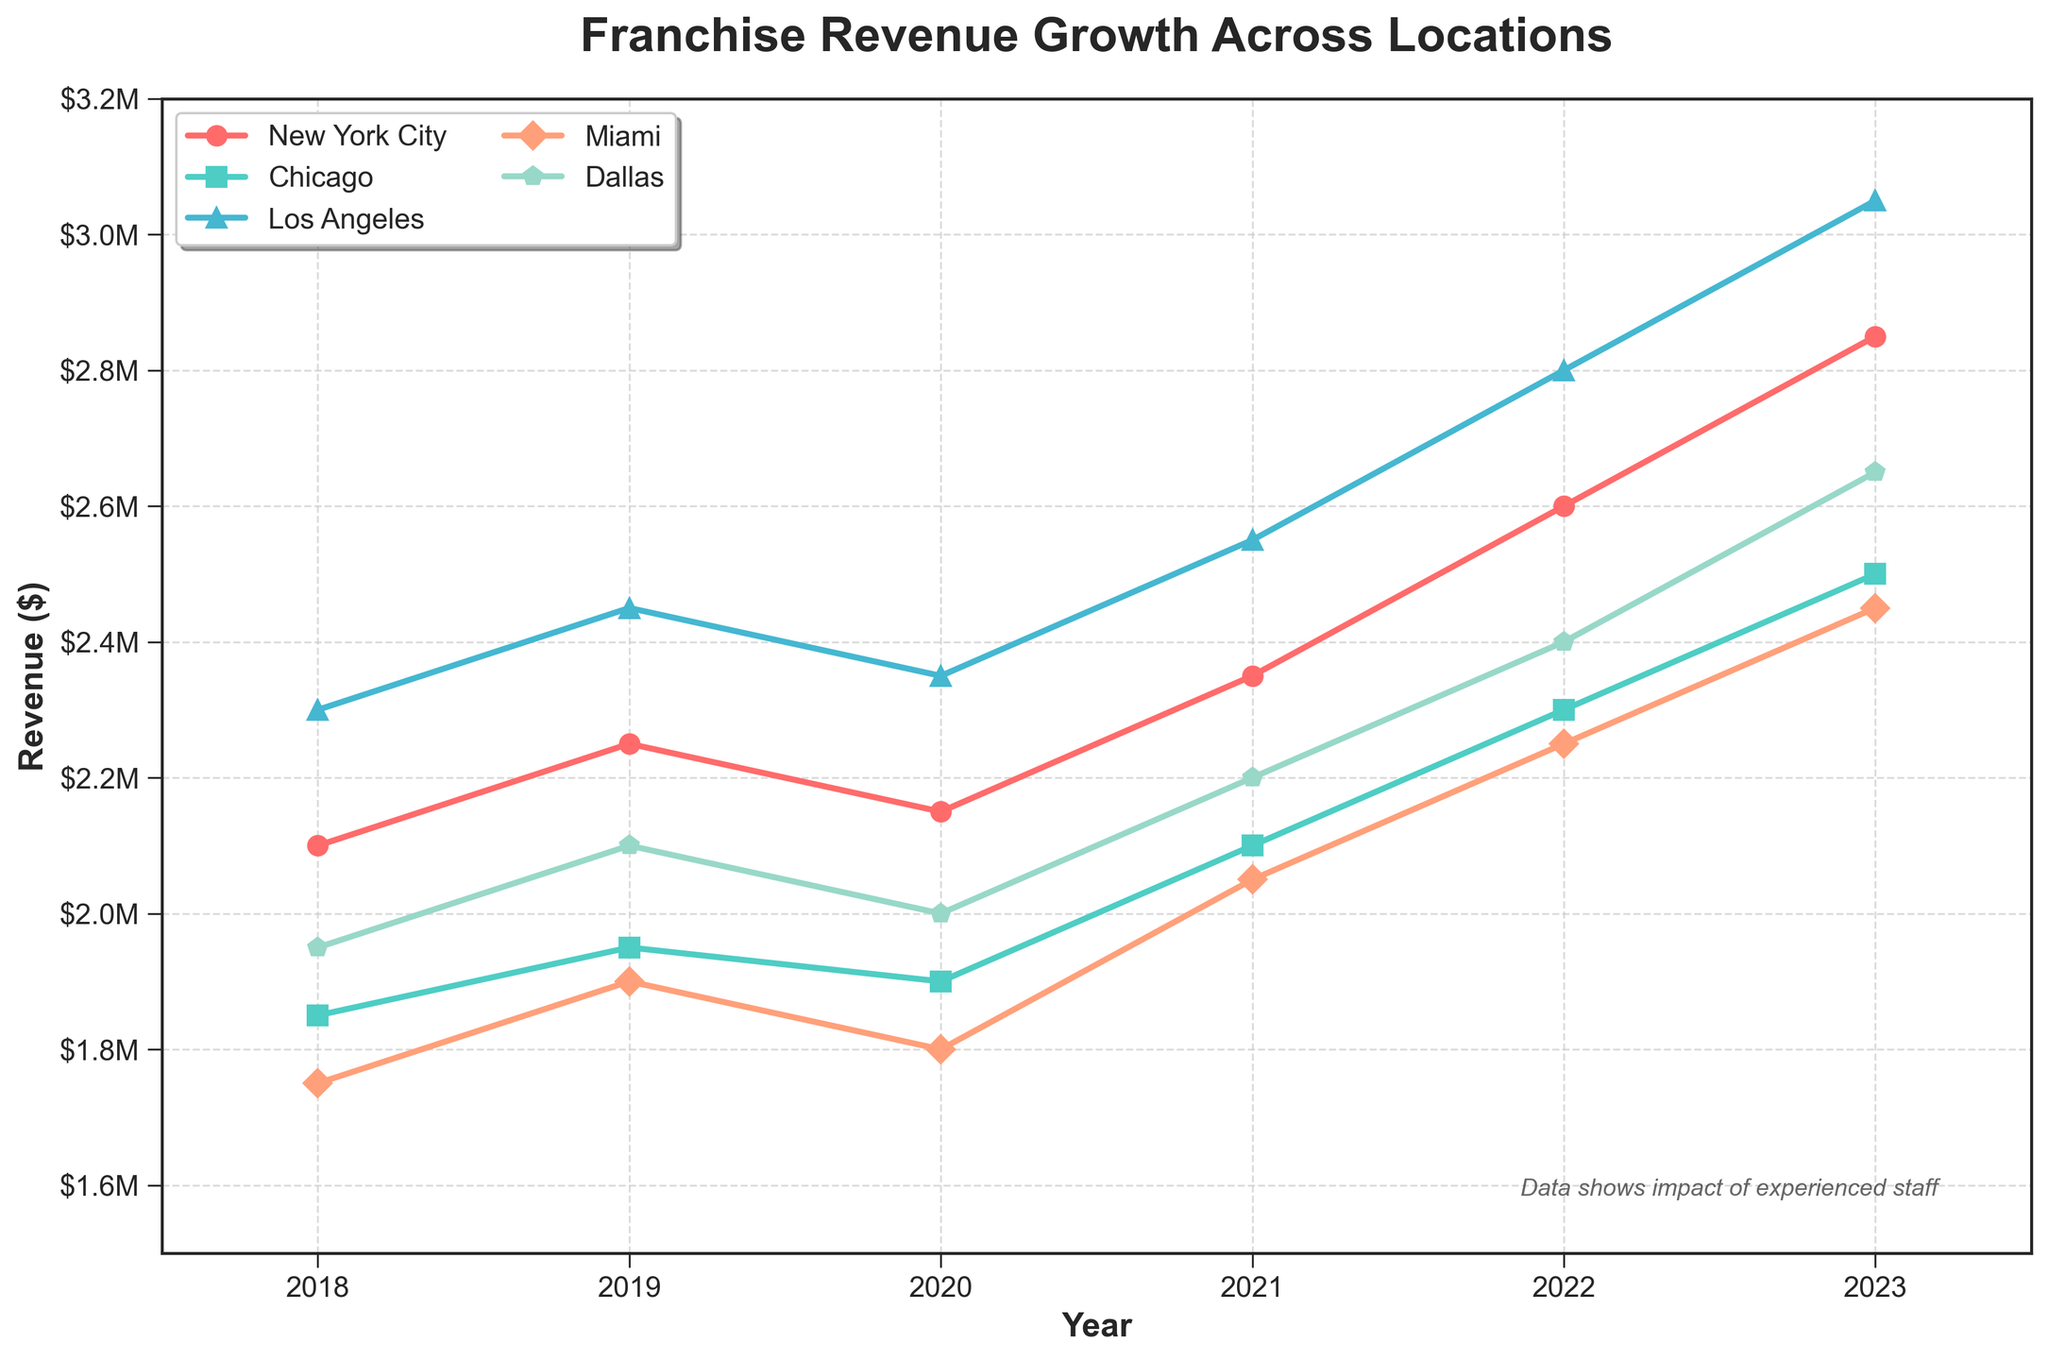What's the difference in revenue between New York City and Dallas in 2023? Locate the revenue values for New York City and Dallas for 2023: $2,850,000 and $2,650,000, respectively. Subtract the Dallas revenue from the New York City revenue: $2,850,000 - $2,650,000 = $200,000
Answer: $200,000 Which location experienced the highest growth in revenue from 2022 to 2023? Calculate the growth for each location: 
- New York City: $2,850,000 - $2,600,000 = $250,000 
- Chicago: $2,500,000 - $2,300,000 = $200,000 
- Los Angeles: $3,050,000 - $2,800,000 = $250,000 
- Miami: $2,450,000 - $2,250,000 = $200,000 
- Dallas: $2,650,000 - $2,400,000 = $250,000
New York City, Los Angeles, and Dallas had the highest growth of $250,000.
Answer: New York City, Los Angeles, Dallas Which location had the lowest revenue in 2020? Locate the revenue for each location in 2020: New York City ($2,150,000), Chicago ($1,900,000), Los Angeles ($2,350,000), Miami ($1,800,000), Dallas ($2,000,000). The lowest revenue was in Miami with $1,800,000.
Answer: Miami How does the revenue trend for Los Angeles compare with that of Miami over the years? Observe the line patterns for Los Angeles and Miami. Both have increasing trends over time:
- Los Angeles moved from $2,300,000 in 2018 to $3,050,000 in 2023.
- Miami moved from $1,750,000 in 2018 to $2,450,000 in 2023.
Los Angeles had a consistently higher revenue and higher growth increment compared to Miami.
Answer: Los Angeles had higher revenue and growth What is the average annual revenue for Chicago from 2018 to 2023? Sum the annual revenues for Chicago from 2018 to 2023: $1,850,000 + $1,950,000 + $1,900,000 + $2,100,000 + $2,300,000 + $2,500,000 = $12,600,000. Divide by the number of years: $12,600,000 / 6 ≈ $2,100,000
Answer: $2,100,000 Which years did New York City's revenue decrease compared to the previous year? Check revenues for New York City across each year:
- 2018: $2,100,000
- 2019: $2,250,000 (increase)
- 2020: $2,150,000 (decrease)
- 2021: $2,350,000 (increase)
- 2022: $2,600,000 (increase)
- 2023: $2,850,000 (increase)
New York City's revenue decreased from 2019 to 2020.
Answer: 2020 What was the combined revenue of New York City and Los Angeles in 2021? Locate and sum the revenue for New York City and Los Angeles in 2021: $2,350,000 (New York City) + $2,550,000 (Los Angeles) = $4,900,000
Answer: $4,900,000 In 2023, which city had the closest revenue to $2,500,000? Compare 2023 revenues to $2,500,000:
- New York City: $2,850,000 (higher)
- Chicago: $2,500,000 (equal)
- Los Angeles: $3,050,000 (higher)
- Miami: $2,450,000 (lower)
- Dallas: $2,650,000 (higher)
Chicago had revenue exactly $2,500,000.
Answer: Chicago 